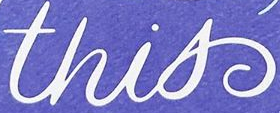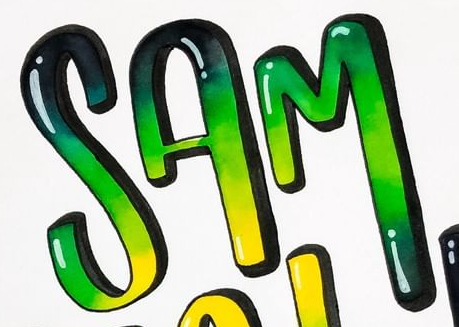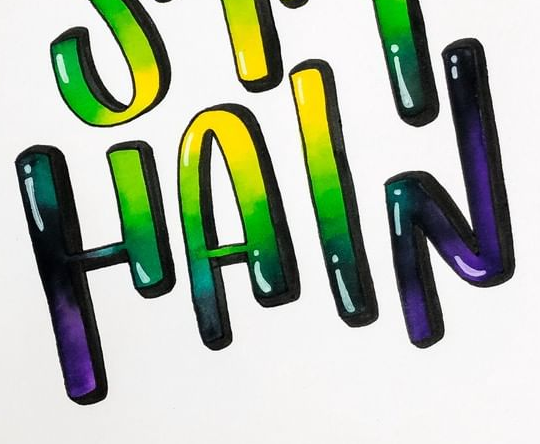What words are shown in these images in order, separated by a semicolon? this; SAM; HAIN 